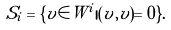<formula> <loc_0><loc_0><loc_500><loc_500>S _ { i } = \{ v \in W ^ { i } | ( v , v ) = 0 \} .</formula> 